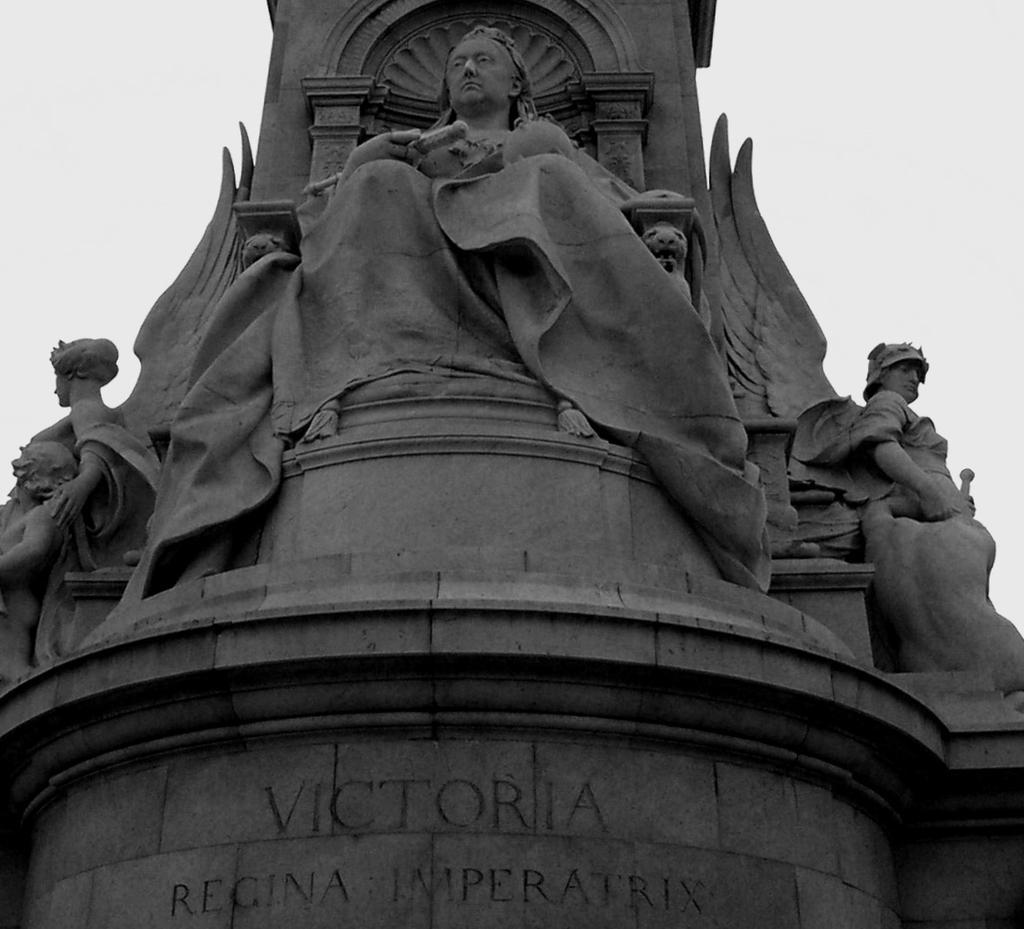Please provide a concise description of this image. In this picture I can see sculptures, there are letters carved on the wall, and in the background there is the sky. 